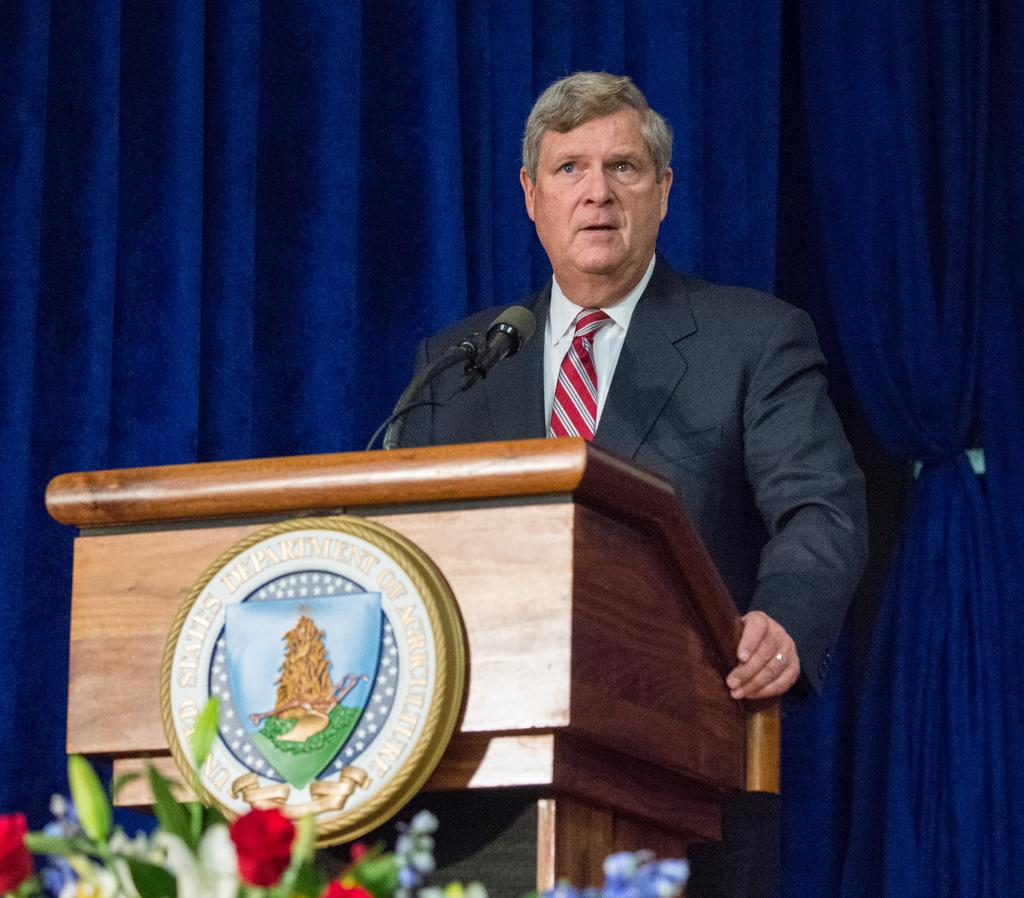What is the man in the image doing? The man is standing in front of a microphone. What object is present near the man? There is a podium in the image. What type of plants can be seen in the image? Flowers and leaves are visible in the image. What can be seen in the background of the image? There are curtains in the background of the image. What is the price of the floor in the image? There is no mention of a floor in the image, and therefore no price can be determined. 